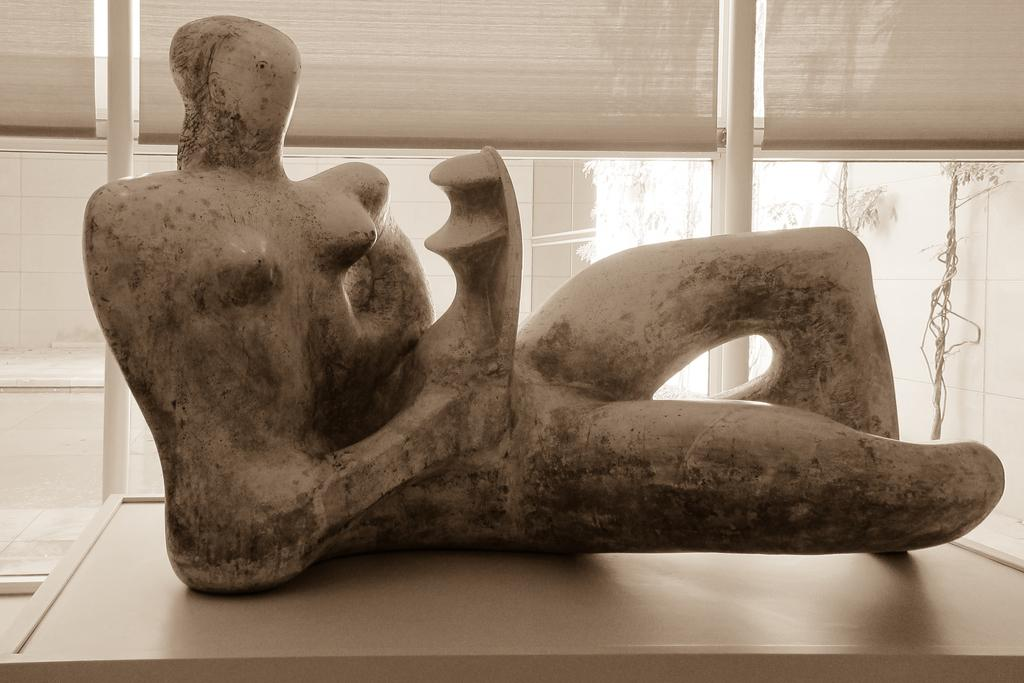What is the main subject in the center of the image? There is a statue in the center of the image. Where is the statue located? The statue is on a table. What can be seen in the background of the image? There are glass windows in the background of the image. How many jellyfish are swimming in the air around the statue in the image? There are no jellyfish present in the image; it only features a statue on a table and glass windows in the background. 